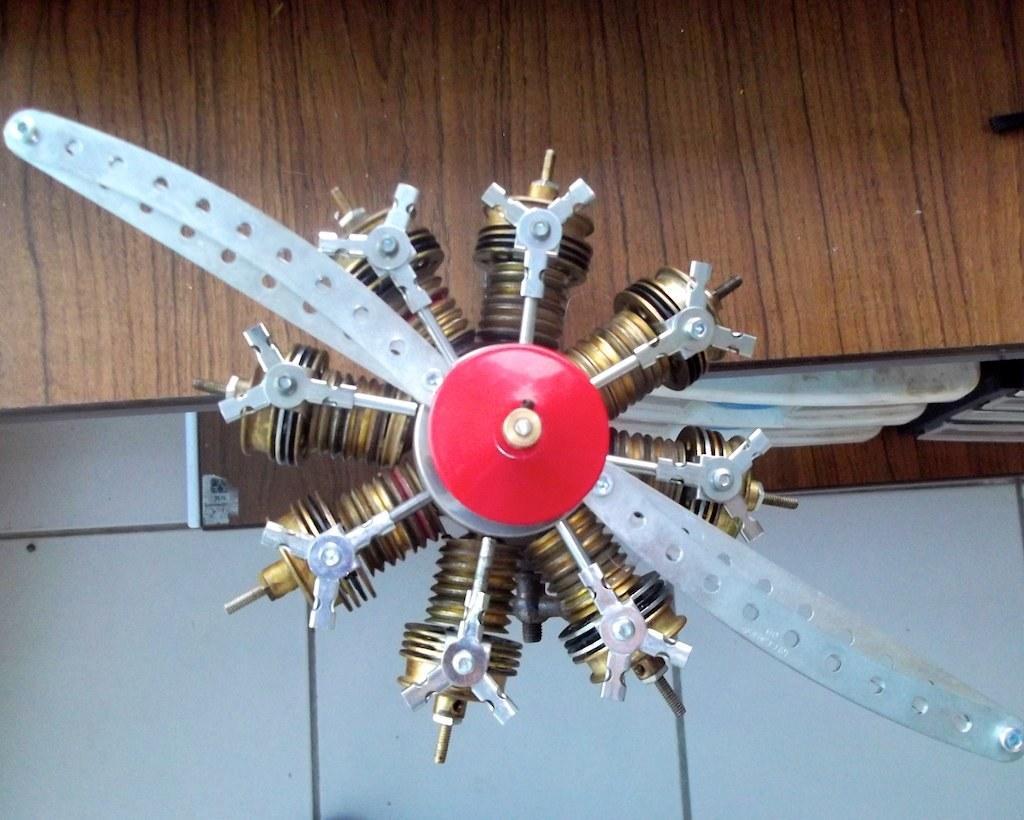Describe this image in one or two sentences. In this picture we can see an object and in the background we can see the wall and some objects. 